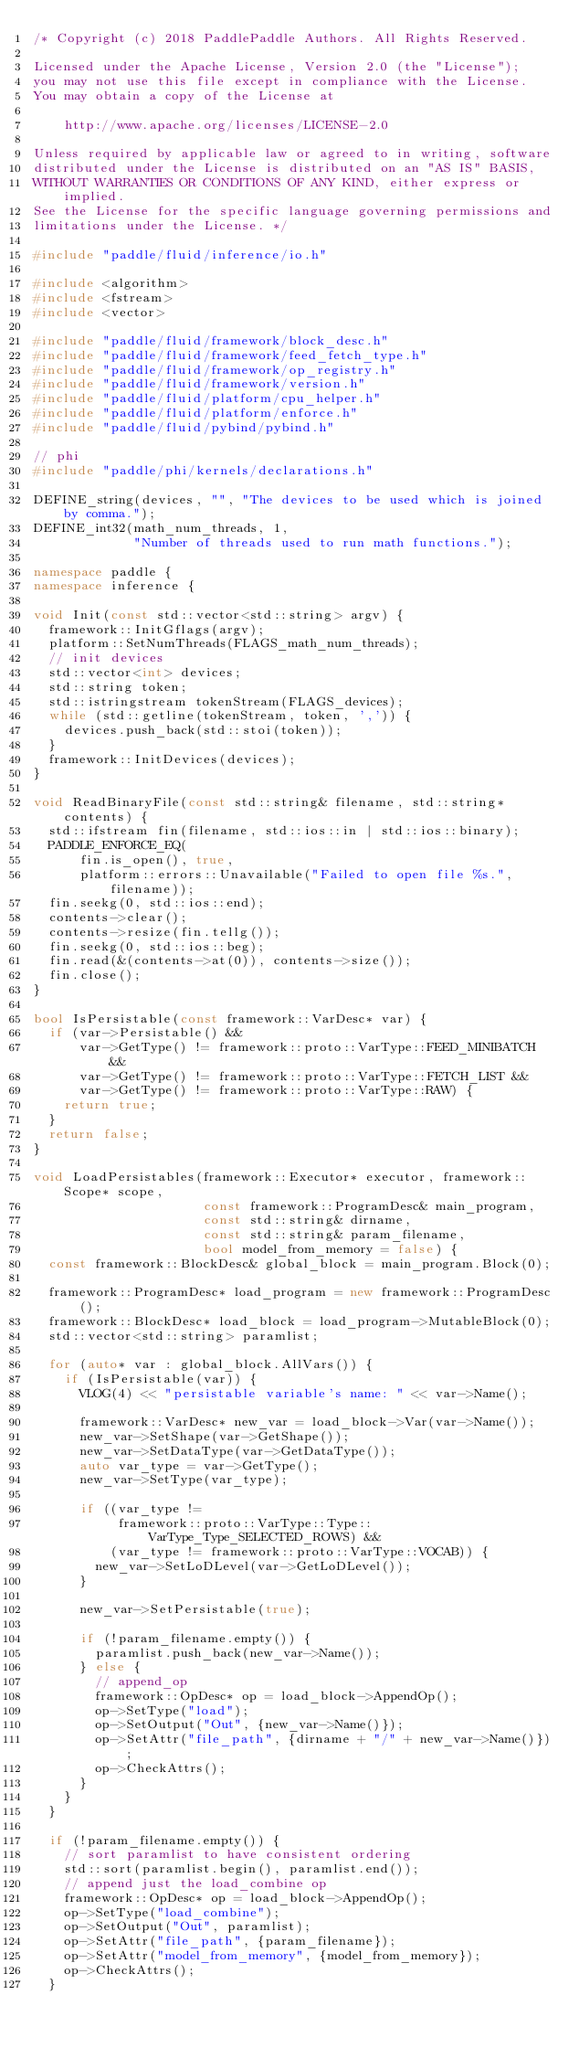Convert code to text. <code><loc_0><loc_0><loc_500><loc_500><_C++_>/* Copyright (c) 2018 PaddlePaddle Authors. All Rights Reserved.

Licensed under the Apache License, Version 2.0 (the "License");
you may not use this file except in compliance with the License.
You may obtain a copy of the License at

    http://www.apache.org/licenses/LICENSE-2.0

Unless required by applicable law or agreed to in writing, software
distributed under the License is distributed on an "AS IS" BASIS,
WITHOUT WARRANTIES OR CONDITIONS OF ANY KIND, either express or implied.
See the License for the specific language governing permissions and
limitations under the License. */

#include "paddle/fluid/inference/io.h"

#include <algorithm>
#include <fstream>
#include <vector>

#include "paddle/fluid/framework/block_desc.h"
#include "paddle/fluid/framework/feed_fetch_type.h"
#include "paddle/fluid/framework/op_registry.h"
#include "paddle/fluid/framework/version.h"
#include "paddle/fluid/platform/cpu_helper.h"
#include "paddle/fluid/platform/enforce.h"
#include "paddle/fluid/pybind/pybind.h"

// phi
#include "paddle/phi/kernels/declarations.h"

DEFINE_string(devices, "", "The devices to be used which is joined by comma.");
DEFINE_int32(math_num_threads, 1,
             "Number of threads used to run math functions.");

namespace paddle {
namespace inference {

void Init(const std::vector<std::string> argv) {
  framework::InitGflags(argv);
  platform::SetNumThreads(FLAGS_math_num_threads);
  // init devices
  std::vector<int> devices;
  std::string token;
  std::istringstream tokenStream(FLAGS_devices);
  while (std::getline(tokenStream, token, ',')) {
    devices.push_back(std::stoi(token));
  }
  framework::InitDevices(devices);
}

void ReadBinaryFile(const std::string& filename, std::string* contents) {
  std::ifstream fin(filename, std::ios::in | std::ios::binary);
  PADDLE_ENFORCE_EQ(
      fin.is_open(), true,
      platform::errors::Unavailable("Failed to open file %s.", filename));
  fin.seekg(0, std::ios::end);
  contents->clear();
  contents->resize(fin.tellg());
  fin.seekg(0, std::ios::beg);
  fin.read(&(contents->at(0)), contents->size());
  fin.close();
}

bool IsPersistable(const framework::VarDesc* var) {
  if (var->Persistable() &&
      var->GetType() != framework::proto::VarType::FEED_MINIBATCH &&
      var->GetType() != framework::proto::VarType::FETCH_LIST &&
      var->GetType() != framework::proto::VarType::RAW) {
    return true;
  }
  return false;
}

void LoadPersistables(framework::Executor* executor, framework::Scope* scope,
                      const framework::ProgramDesc& main_program,
                      const std::string& dirname,
                      const std::string& param_filename,
                      bool model_from_memory = false) {
  const framework::BlockDesc& global_block = main_program.Block(0);

  framework::ProgramDesc* load_program = new framework::ProgramDesc();
  framework::BlockDesc* load_block = load_program->MutableBlock(0);
  std::vector<std::string> paramlist;

  for (auto* var : global_block.AllVars()) {
    if (IsPersistable(var)) {
      VLOG(4) << "persistable variable's name: " << var->Name();

      framework::VarDesc* new_var = load_block->Var(var->Name());
      new_var->SetShape(var->GetShape());
      new_var->SetDataType(var->GetDataType());
      auto var_type = var->GetType();
      new_var->SetType(var_type);

      if ((var_type !=
           framework::proto::VarType::Type::VarType_Type_SELECTED_ROWS) &&
          (var_type != framework::proto::VarType::VOCAB)) {
        new_var->SetLoDLevel(var->GetLoDLevel());
      }

      new_var->SetPersistable(true);

      if (!param_filename.empty()) {
        paramlist.push_back(new_var->Name());
      } else {
        // append_op
        framework::OpDesc* op = load_block->AppendOp();
        op->SetType("load");
        op->SetOutput("Out", {new_var->Name()});
        op->SetAttr("file_path", {dirname + "/" + new_var->Name()});
        op->CheckAttrs();
      }
    }
  }

  if (!param_filename.empty()) {
    // sort paramlist to have consistent ordering
    std::sort(paramlist.begin(), paramlist.end());
    // append just the load_combine op
    framework::OpDesc* op = load_block->AppendOp();
    op->SetType("load_combine");
    op->SetOutput("Out", paramlist);
    op->SetAttr("file_path", {param_filename});
    op->SetAttr("model_from_memory", {model_from_memory});
    op->CheckAttrs();
  }
</code> 